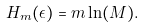Convert formula to latex. <formula><loc_0><loc_0><loc_500><loc_500>H _ { m } ( \epsilon ) = m \ln ( M ) .</formula> 